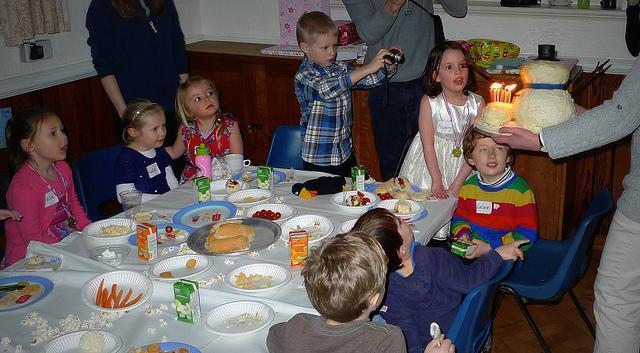How many people are in the picture?
Give a very brief answer. 11. How many chairs can be seen?
Give a very brief answer. 3. How many people can you see?
Give a very brief answer. 11. 